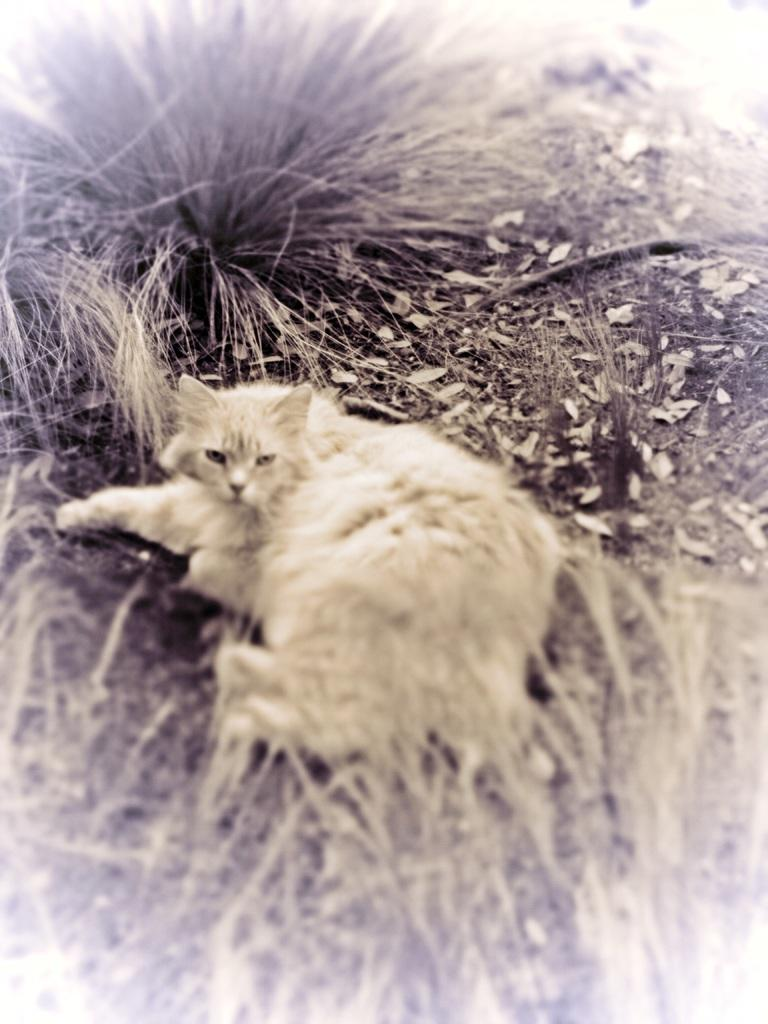What type of animal is in the picture? There is a cat in the picture. What is the cat doing in the image? The cat is laying down. What type of vegetation is at the bottom of the image? There is grass at the bottom of the image. What else can be seen in the image besides the cat and grass? There are leaves visible in the image. Can you tell me how many snails are crawling on the cup in the image? There is no cup or snails present in the image; it features a cat laying down on grass with leaves visible. 